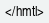<code> <loc_0><loc_0><loc_500><loc_500><_PHP_></hmtl></code> 